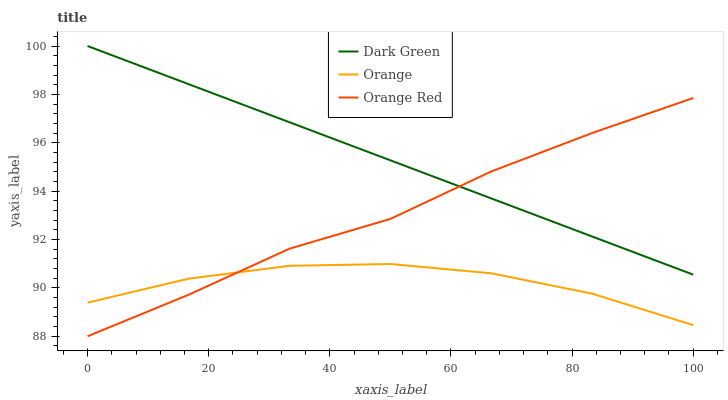Does Orange have the minimum area under the curve?
Answer yes or no. Yes. Does Dark Green have the maximum area under the curve?
Answer yes or no. Yes. Does Orange Red have the minimum area under the curve?
Answer yes or no. No. Does Orange Red have the maximum area under the curve?
Answer yes or no. No. Is Dark Green the smoothest?
Answer yes or no. Yes. Is Orange the roughest?
Answer yes or no. Yes. Is Orange Red the smoothest?
Answer yes or no. No. Is Orange Red the roughest?
Answer yes or no. No. Does Orange Red have the lowest value?
Answer yes or no. Yes. Does Dark Green have the lowest value?
Answer yes or no. No. Does Dark Green have the highest value?
Answer yes or no. Yes. Does Orange Red have the highest value?
Answer yes or no. No. Is Orange less than Dark Green?
Answer yes or no. Yes. Is Dark Green greater than Orange?
Answer yes or no. Yes. Does Dark Green intersect Orange Red?
Answer yes or no. Yes. Is Dark Green less than Orange Red?
Answer yes or no. No. Is Dark Green greater than Orange Red?
Answer yes or no. No. Does Orange intersect Dark Green?
Answer yes or no. No. 